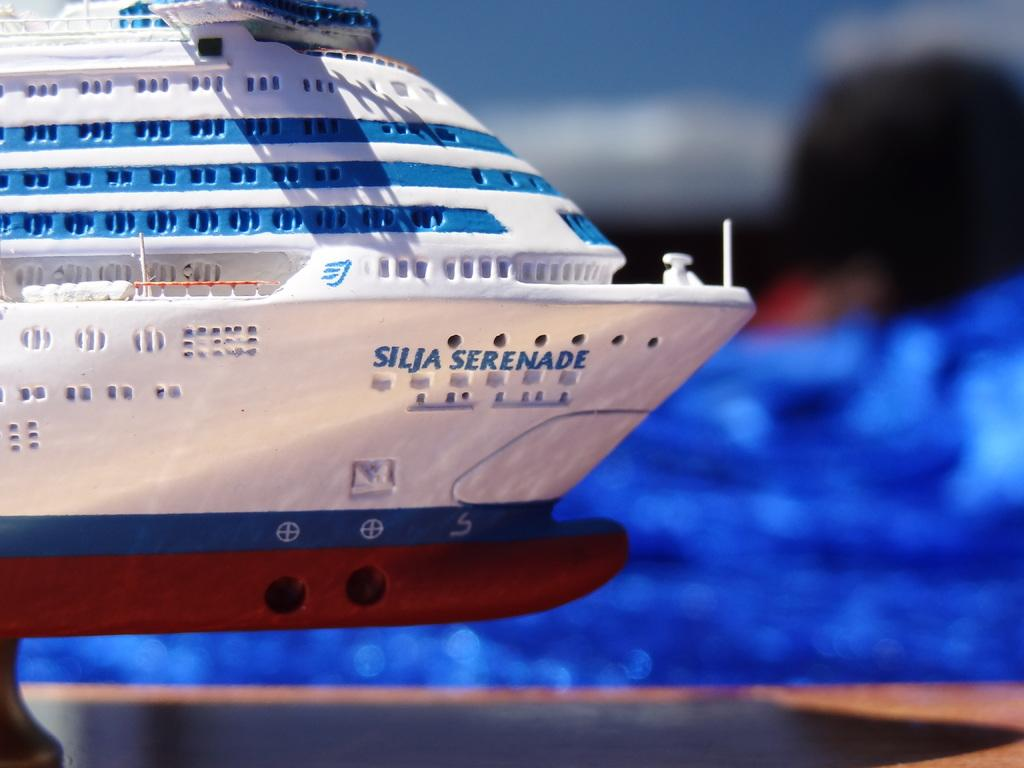What is located on the left side of the image? There is a toy boat on the left side of the image. What can be seen on the ground in the image? There are objects on the ground in the image. Can you describe the clarity of the image? The image is blurred. What type of brain is visible in the image? There is no brain visible in the image. What kind of zephyr can be seen blowing through the scene in the image? There is no zephyr present in the image. 